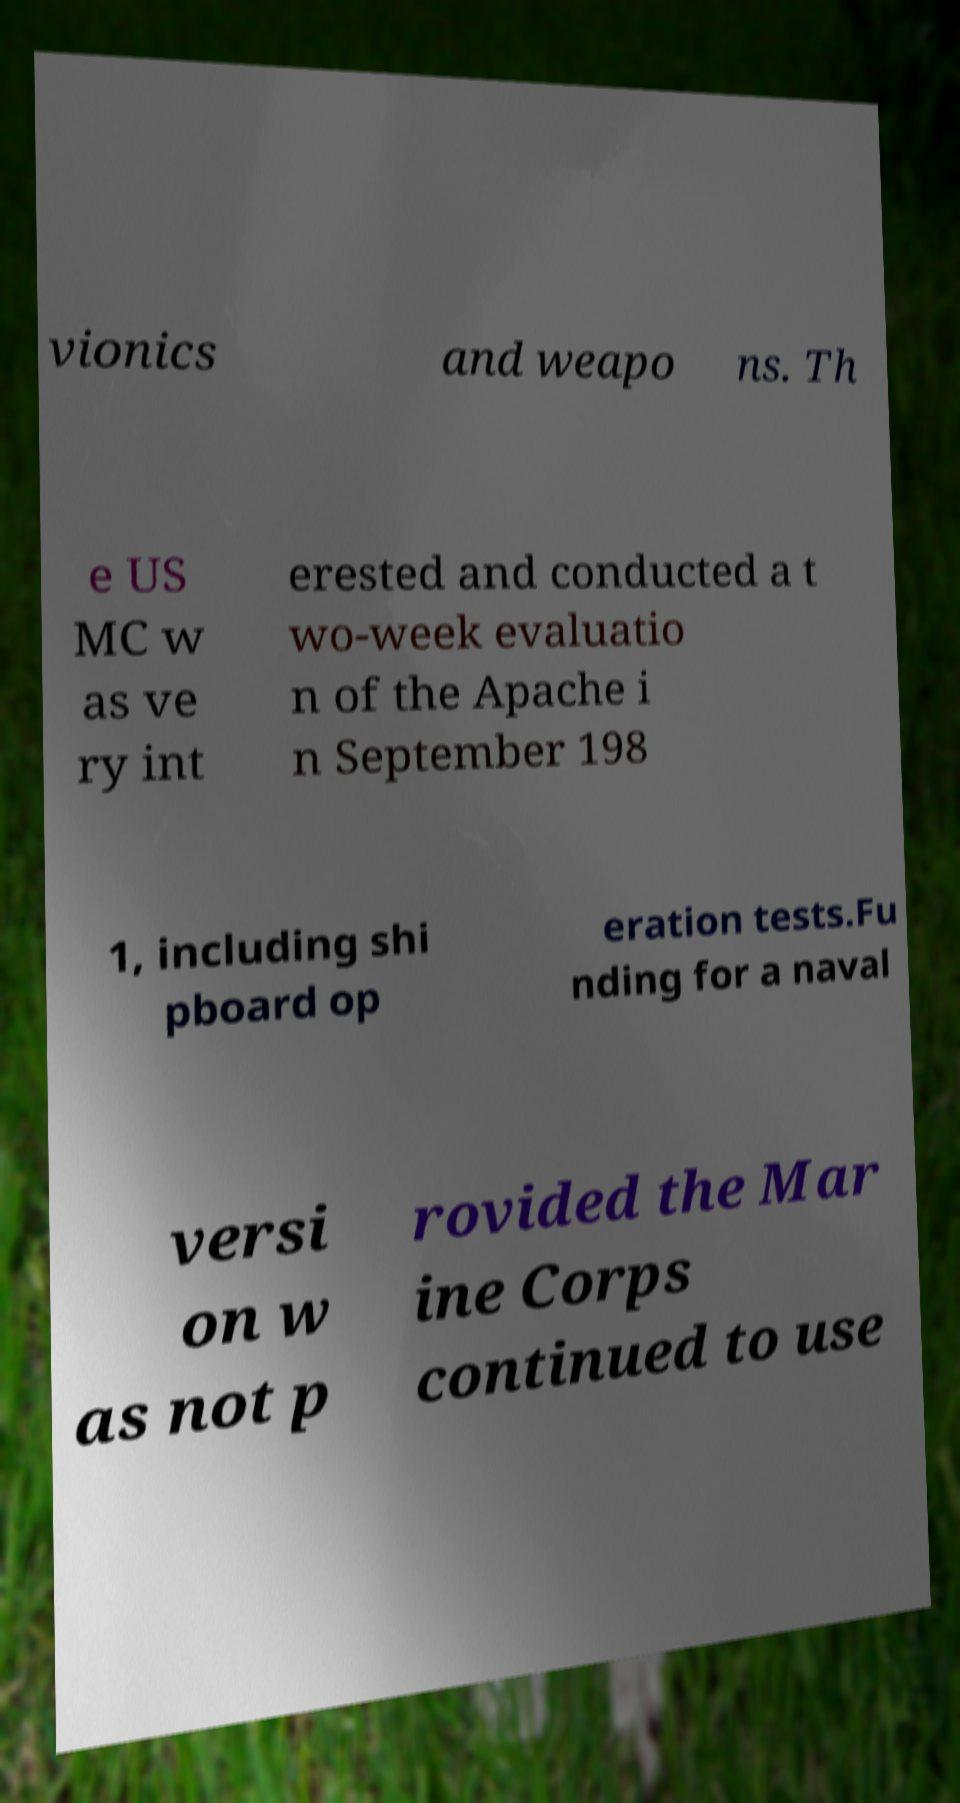Can you read and provide the text displayed in the image?This photo seems to have some interesting text. Can you extract and type it out for me? vionics and weapo ns. Th e US MC w as ve ry int erested and conducted a t wo-week evaluatio n of the Apache i n September 198 1, including shi pboard op eration tests.Fu nding for a naval versi on w as not p rovided the Mar ine Corps continued to use 